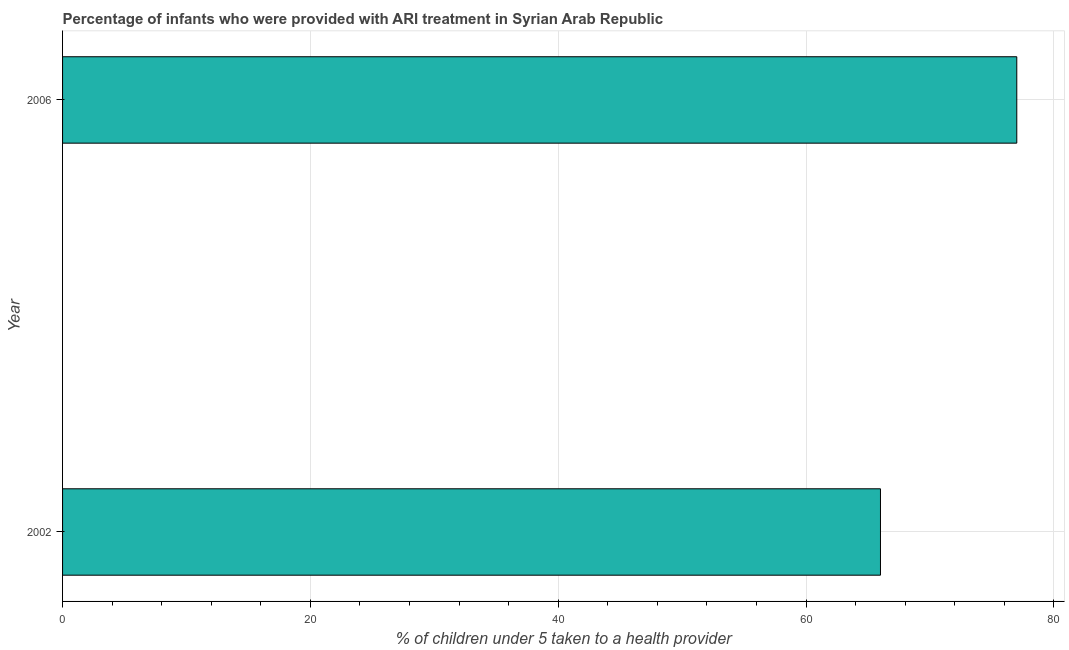What is the title of the graph?
Keep it short and to the point. Percentage of infants who were provided with ARI treatment in Syrian Arab Republic. What is the label or title of the X-axis?
Your answer should be compact. % of children under 5 taken to a health provider. What is the label or title of the Y-axis?
Offer a terse response. Year. In which year was the percentage of children who were provided with ari treatment maximum?
Keep it short and to the point. 2006. What is the sum of the percentage of children who were provided with ari treatment?
Provide a succinct answer. 143. What is the difference between the percentage of children who were provided with ari treatment in 2002 and 2006?
Provide a succinct answer. -11. What is the average percentage of children who were provided with ari treatment per year?
Keep it short and to the point. 71. What is the median percentage of children who were provided with ari treatment?
Your response must be concise. 71.5. Do a majority of the years between 2002 and 2006 (inclusive) have percentage of children who were provided with ari treatment greater than 24 %?
Provide a short and direct response. Yes. What is the ratio of the percentage of children who were provided with ari treatment in 2002 to that in 2006?
Keep it short and to the point. 0.86. Is the percentage of children who were provided with ari treatment in 2002 less than that in 2006?
Give a very brief answer. Yes. In how many years, is the percentage of children who were provided with ari treatment greater than the average percentage of children who were provided with ari treatment taken over all years?
Your answer should be compact. 1. How many bars are there?
Provide a succinct answer. 2. Are all the bars in the graph horizontal?
Provide a succinct answer. Yes. What is the difference between two consecutive major ticks on the X-axis?
Offer a very short reply. 20. What is the ratio of the % of children under 5 taken to a health provider in 2002 to that in 2006?
Your answer should be very brief. 0.86. 